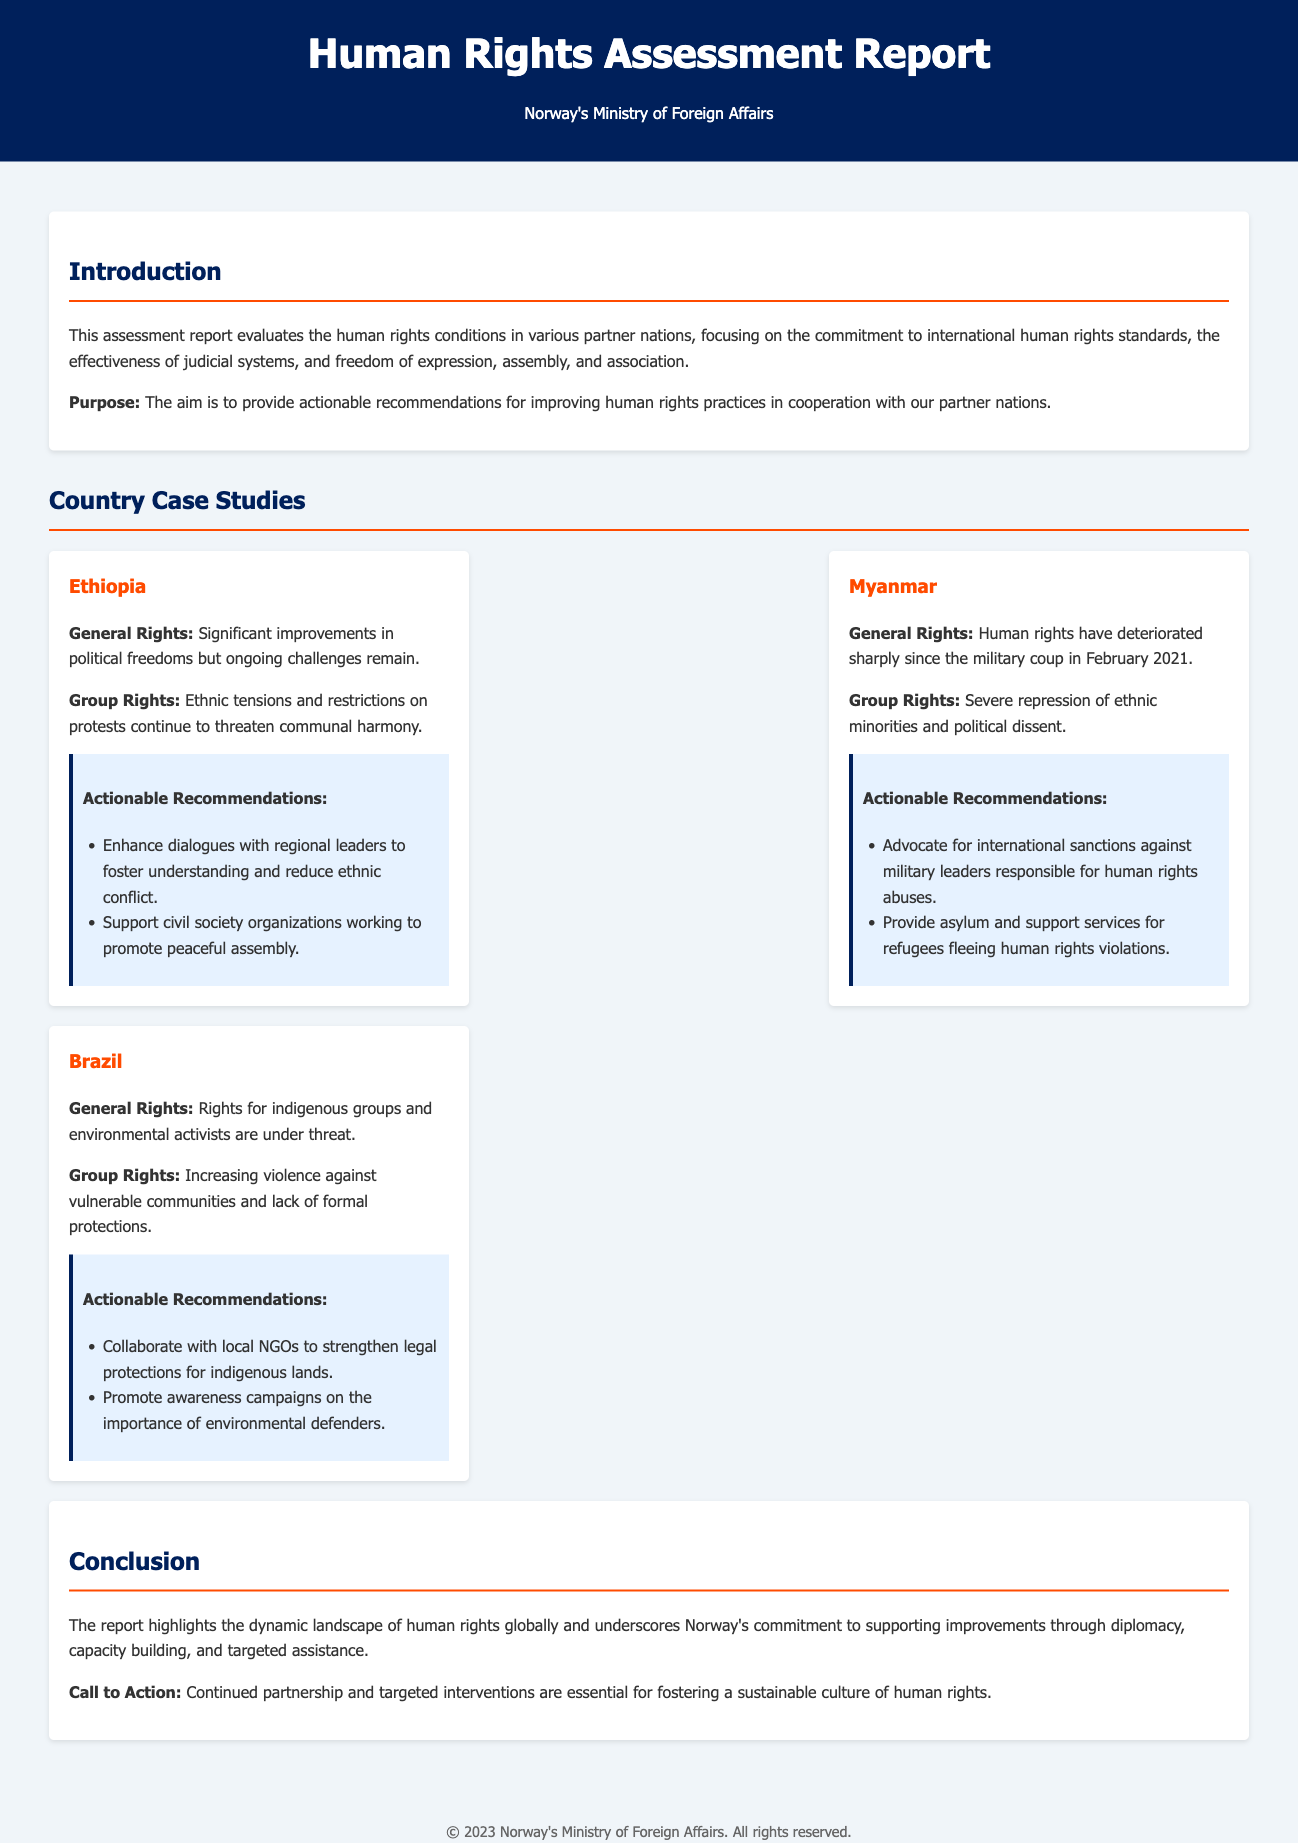what is the title of the report? The title of the report is presented prominently at the top of the document.
Answer: Human Rights Assessment Report who published the report? The publisher of the report is mentioned in the header section.
Answer: Norway's Ministry of Foreign Affairs which country had significant improvements in political freedoms? Information about this country's status is provided under the case studies.
Answer: Ethiopia what major event negatively affected human rights in Myanmar? The event that impacted human rights in Myanmar is described in the case study section.
Answer: Military coup what kind of rights are under threat in Brazil? The specific rights mentioned in the report regarding Brazil are outlined in its case study.
Answer: Rights for indigenous groups and environmental activists what is one recommendation for Ethiopia? One actionable recommendation for Ethiopia is included in the recommendations section under its case study.
Answer: Enhance dialogues with regional leaders what does the conclusion emphasize about Norway's role? The role of Norway is summarized in the conclusion section, highlighting its actions regarding human rights.
Answer: Supporting improvements through diplomacy what is the purpose of the assessment report? The purpose is stated clearly in the introduction section.
Answer: Provide actionable recommendations 